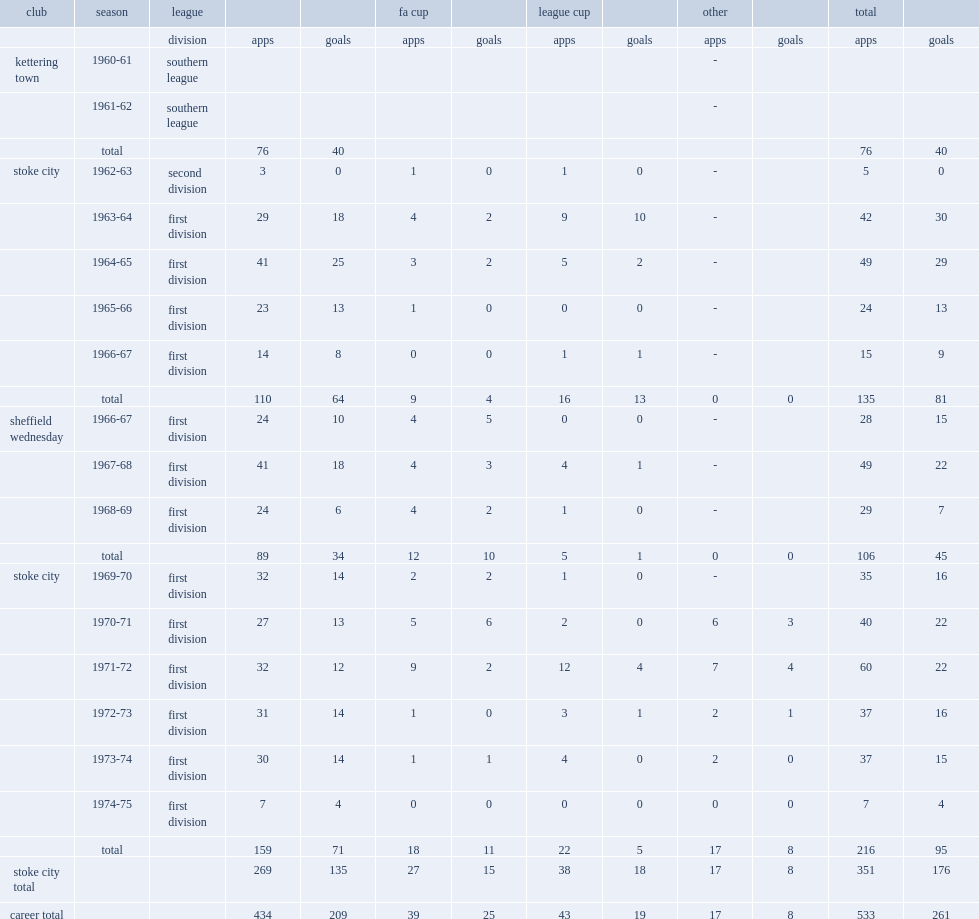How many goals did john ritchie score for stoke? 176.0. Help me parse the entirety of this table. {'header': ['club', 'season', 'league', '', '', 'fa cup', '', 'league cup', '', 'other', '', 'total', ''], 'rows': [['', '', 'division', 'apps', 'goals', 'apps', 'goals', 'apps', 'goals', 'apps', 'goals', 'apps', 'goals'], ['kettering town', '1960-61', 'southern league', '', '', '', '', '', '', '-', '', '', ''], ['', '1961-62', 'southern league', '', '', '', '', '', '', '-', '', '', ''], ['', 'total', '', '76', '40', '', '', '', '', '', '', '76', '40'], ['stoke city', '1962-63', 'second division', '3', '0', '1', '0', '1', '0', '-', '', '5', '0'], ['', '1963-64', 'first division', '29', '18', '4', '2', '9', '10', '-', '', '42', '30'], ['', '1964-65', 'first division', '41', '25', '3', '2', '5', '2', '-', '', '49', '29'], ['', '1965-66', 'first division', '23', '13', '1', '0', '0', '0', '-', '', '24', '13'], ['', '1966-67', 'first division', '14', '8', '0', '0', '1', '1', '-', '', '15', '9'], ['', 'total', '', '110', '64', '9', '4', '16', '13', '0', '0', '135', '81'], ['sheffield wednesday', '1966-67', 'first division', '24', '10', '4', '5', '0', '0', '-', '', '28', '15'], ['', '1967-68', 'first division', '41', '18', '4', '3', '4', '1', '-', '', '49', '22'], ['', '1968-69', 'first division', '24', '6', '4', '2', '1', '0', '-', '', '29', '7'], ['', 'total', '', '89', '34', '12', '10', '5', '1', '0', '0', '106', '45'], ['stoke city', '1969-70', 'first division', '32', '14', '2', '2', '1', '0', '-', '', '35', '16'], ['', '1970-71', 'first division', '27', '13', '5', '6', '2', '0', '6', '3', '40', '22'], ['', '1971-72', 'first division', '32', '12', '9', '2', '12', '4', '7', '4', '60', '22'], ['', '1972-73', 'first division', '31', '14', '1', '0', '3', '1', '2', '1', '37', '16'], ['', '1973-74', 'first division', '30', '14', '1', '1', '4', '0', '2', '0', '37', '15'], ['', '1974-75', 'first division', '7', '4', '0', '0', '0', '0', '0', '0', '7', '4'], ['', 'total', '', '159', '71', '18', '11', '22', '5', '17', '8', '216', '95'], ['stoke city total', '', '', '269', '135', '27', '15', '38', '18', '17', '8', '351', '176'], ['career total', '', '', '434', '209', '39', '25', '43', '19', '17', '8', '533', '261']]} 